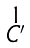Convert formula to latex. <formula><loc_0><loc_0><loc_500><loc_500>\begin{smallmatrix} 1 \\ C ^ { \prime } \end{smallmatrix}</formula> 